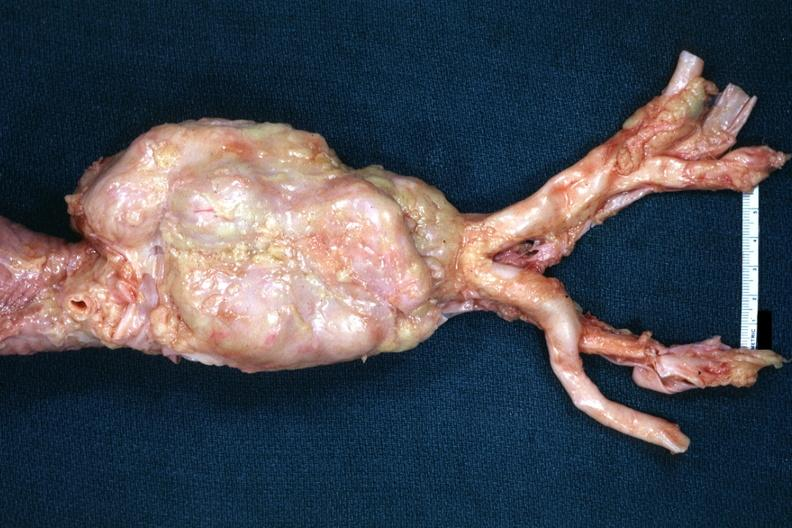what does this image show?
Answer the question using a single word or phrase. Abdominal periaortic node showing massive enlargement very good example 